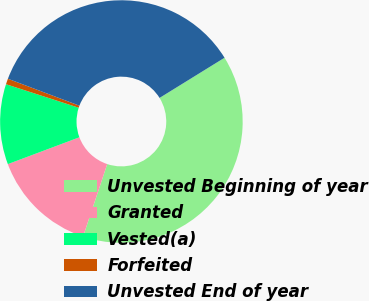Convert chart. <chart><loc_0><loc_0><loc_500><loc_500><pie_chart><fcel>Unvested Beginning of year<fcel>Granted<fcel>Vested(a)<fcel>Forfeited<fcel>Unvested End of year<nl><fcel>38.93%<fcel>14.17%<fcel>10.69%<fcel>0.76%<fcel>35.45%<nl></chart> 